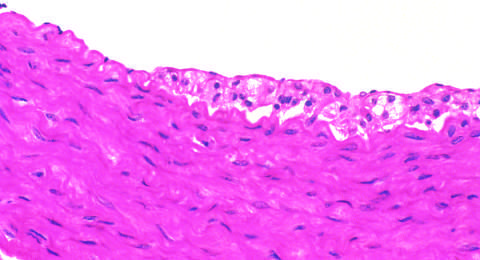what demonstrates intimal, macrophage-derived foam cells?
Answer the question using a single word or phrase. Fatty streak in an experimental hypercholesterolemic rabbit 